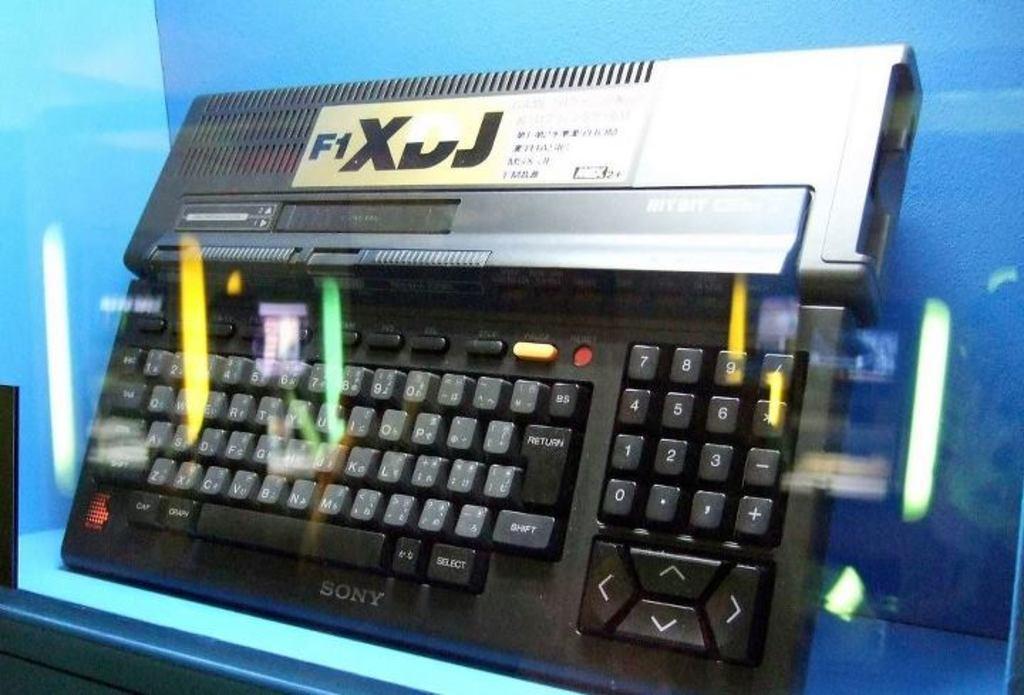In one or two sentences, can you explain what this image depicts? In the image there is a keyboard kept on a blue object and the picture is captured through a glass. 